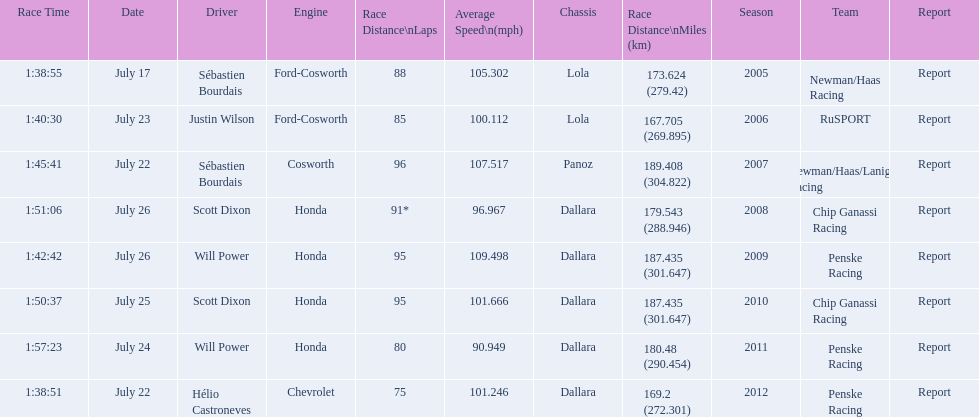How many total honda engines were there? 4. 